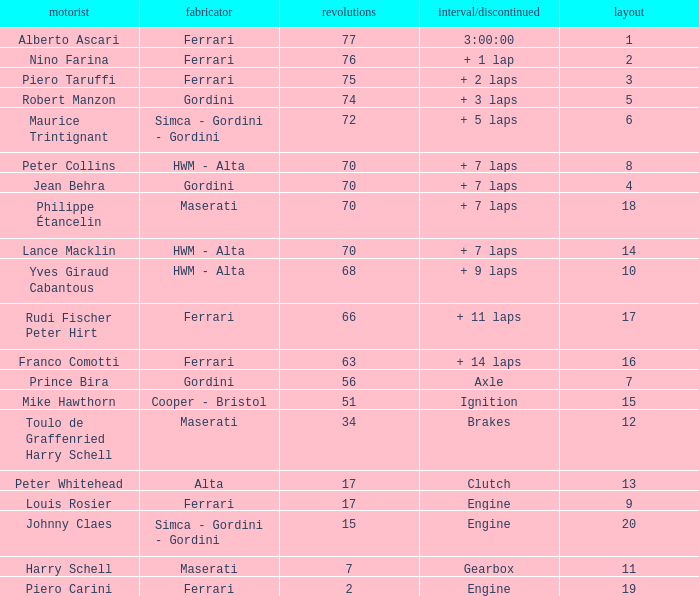What is the high grid for ferrari's with 2 laps? 19.0. Parse the table in full. {'header': ['motorist', 'fabricator', 'revolutions', 'interval/discontinued', 'layout'], 'rows': [['Alberto Ascari', 'Ferrari', '77', '3:00:00', '1'], ['Nino Farina', 'Ferrari', '76', '+ 1 lap', '2'], ['Piero Taruffi', 'Ferrari', '75', '+ 2 laps', '3'], ['Robert Manzon', 'Gordini', '74', '+ 3 laps', '5'], ['Maurice Trintignant', 'Simca - Gordini - Gordini', '72', '+ 5 laps', '6'], ['Peter Collins', 'HWM - Alta', '70', '+ 7 laps', '8'], ['Jean Behra', 'Gordini', '70', '+ 7 laps', '4'], ['Philippe Étancelin', 'Maserati', '70', '+ 7 laps', '18'], ['Lance Macklin', 'HWM - Alta', '70', '+ 7 laps', '14'], ['Yves Giraud Cabantous', 'HWM - Alta', '68', '+ 9 laps', '10'], ['Rudi Fischer Peter Hirt', 'Ferrari', '66', '+ 11 laps', '17'], ['Franco Comotti', 'Ferrari', '63', '+ 14 laps', '16'], ['Prince Bira', 'Gordini', '56', 'Axle', '7'], ['Mike Hawthorn', 'Cooper - Bristol', '51', 'Ignition', '15'], ['Toulo de Graffenried Harry Schell', 'Maserati', '34', 'Brakes', '12'], ['Peter Whitehead', 'Alta', '17', 'Clutch', '13'], ['Louis Rosier', 'Ferrari', '17', 'Engine', '9'], ['Johnny Claes', 'Simca - Gordini - Gordini', '15', 'Engine', '20'], ['Harry Schell', 'Maserati', '7', 'Gearbox', '11'], ['Piero Carini', 'Ferrari', '2', 'Engine', '19']]} 